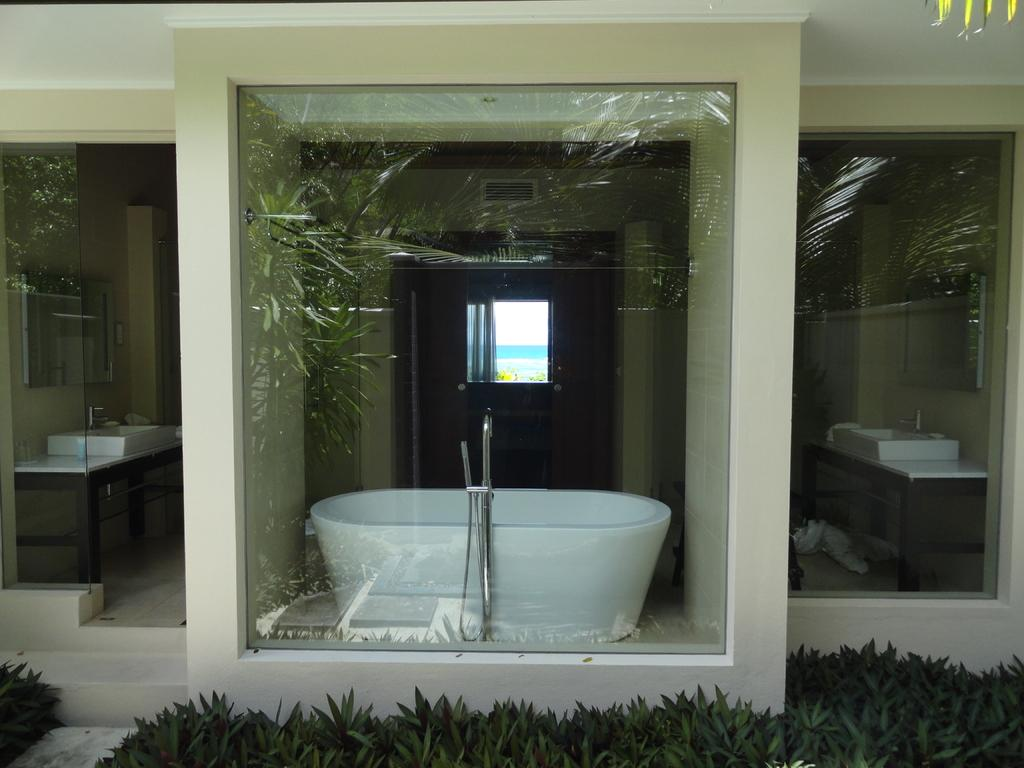What type of living organisms can be seen in the image? Plants are visible in the image. What material is present in the image that is transparent or translucent? A: Glass is present in the image. What can be seen through the glass in the image? A bathtub is visible through the glass. What is the purpose of the tap in the image? The tap is used for controlling the flow of water. How many sinks with taps are present in the image? There are sinks with taps present in the image. What type of architectural feature is visible in the image? Walls are visible in the image. What feature allows natural light to enter the room in the image? There is a window in the image. What type of watch can be seen on the wrist of the person in the image? There is no person present in the image, so no watch can be seen on a wrist. What type of rake is used to maintain the plants in the image? There is no rake present in the image; the plants are not being maintained in this context. 